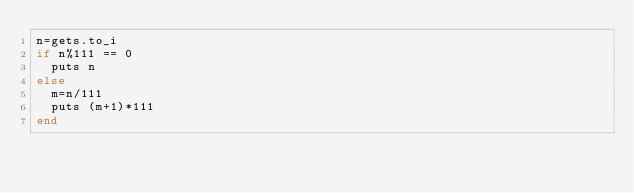<code> <loc_0><loc_0><loc_500><loc_500><_Ruby_>n=gets.to_i
if n%111 == 0
  puts n
else
  m=n/111
  puts (m+1)*111
end</code> 